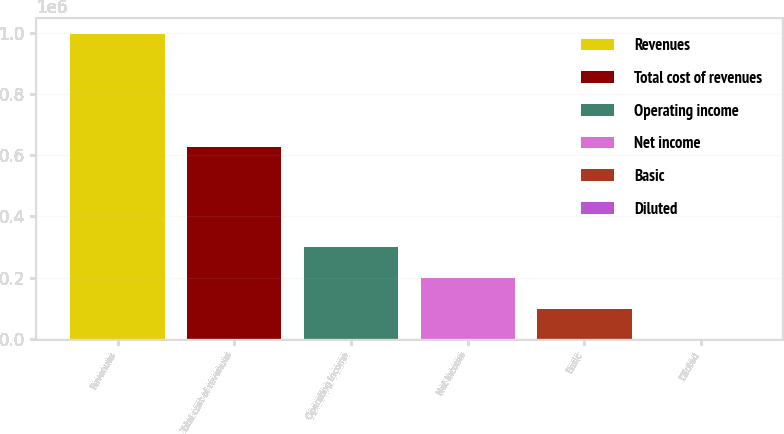Convert chart. <chart><loc_0><loc_0><loc_500><loc_500><bar_chart><fcel>Revenues<fcel>Total cost of revenues<fcel>Operating income<fcel>Net income<fcel>Basic<fcel>Diluted<nl><fcel>996660<fcel>626985<fcel>298998<fcel>199333<fcel>99666.6<fcel>0.71<nl></chart> 